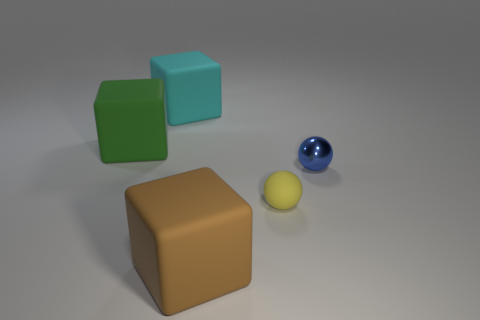Add 1 purple matte cylinders. How many objects exist? 6 Subtract all big cyan blocks. How many blocks are left? 2 Subtract 2 balls. How many balls are left? 0 Subtract all gray cubes. How many yellow spheres are left? 1 Subtract all small gray matte things. Subtract all matte things. How many objects are left? 1 Add 4 cyan rubber blocks. How many cyan rubber blocks are left? 5 Add 5 small gray metal cubes. How many small gray metal cubes exist? 5 Subtract all blue spheres. How many spheres are left? 1 Subtract 0 green balls. How many objects are left? 5 Subtract all balls. How many objects are left? 3 